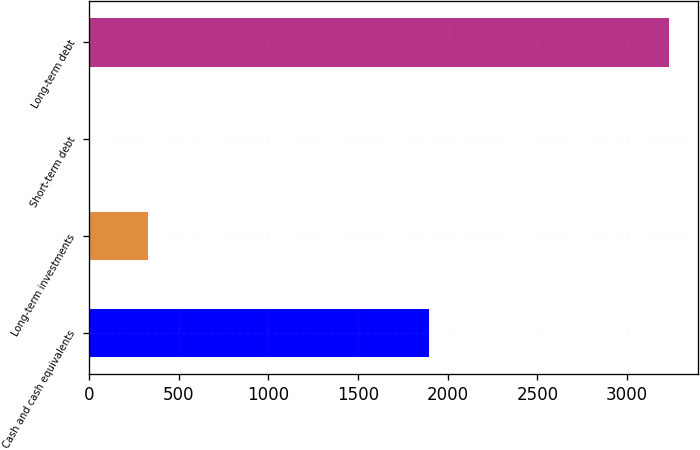Convert chart to OTSL. <chart><loc_0><loc_0><loc_500><loc_500><bar_chart><fcel>Cash and cash equivalents<fcel>Long-term investments<fcel>Short-term debt<fcel>Long-term debt<nl><fcel>1894<fcel>330.6<fcel>8<fcel>3234<nl></chart> 